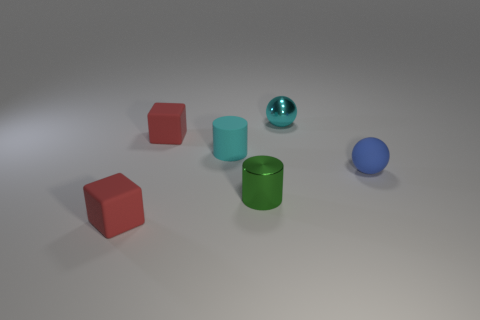How many matte objects are either cylinders or tiny green things?
Ensure brevity in your answer.  1. What is the color of the metallic ball that is the same size as the green metallic object?
Offer a very short reply. Cyan. What number of small cyan metal objects have the same shape as the tiny blue rubber thing?
Give a very brief answer. 1. What number of blocks are either tiny rubber things or red rubber objects?
Provide a succinct answer. 2. Do the rubber object in front of the small green shiny thing and the shiny object that is behind the blue object have the same shape?
Your answer should be compact. No. What material is the small cyan ball?
Ensure brevity in your answer.  Metal. What is the shape of the rubber thing that is the same color as the small metallic sphere?
Give a very brief answer. Cylinder. What number of blocks are the same size as the blue sphere?
Offer a terse response. 2. How many objects are either balls that are to the right of the cyan sphere or tiny things that are to the left of the blue sphere?
Make the answer very short. 6. Is the material of the cylinder to the right of the cyan cylinder the same as the tiny cylinder behind the tiny green cylinder?
Ensure brevity in your answer.  No. 